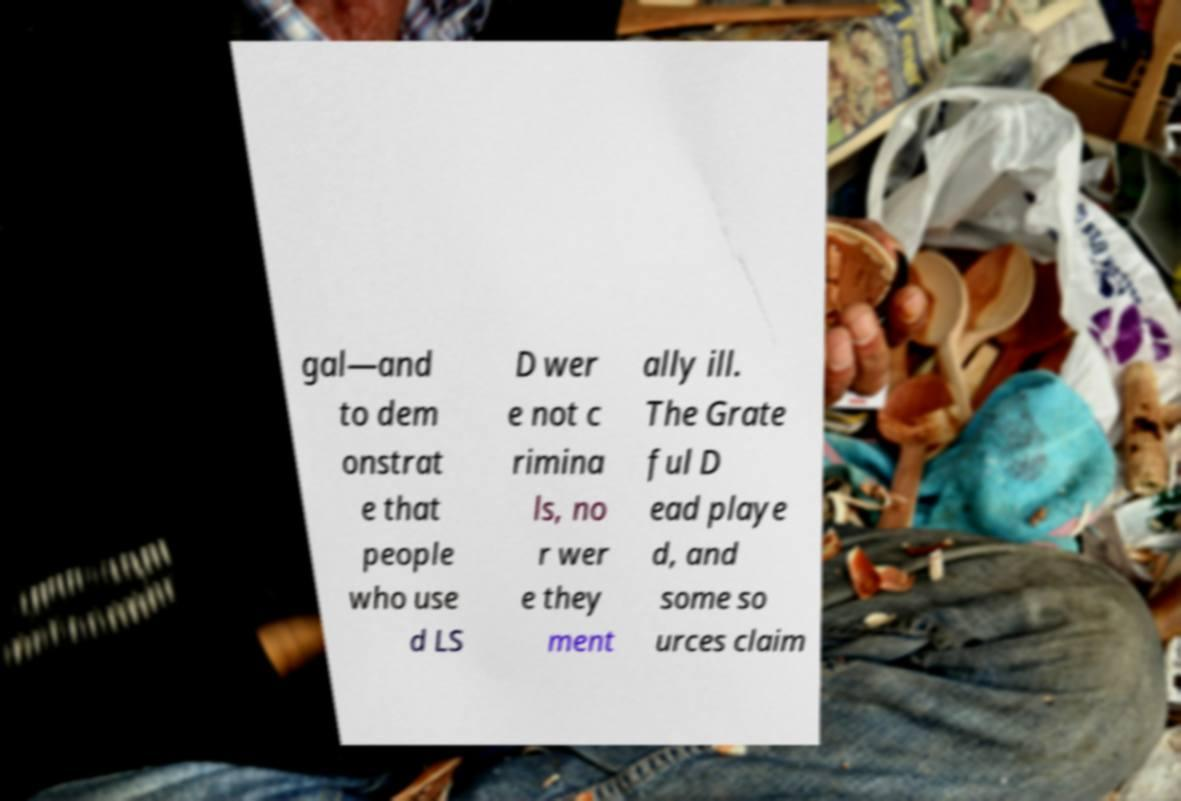Can you read and provide the text displayed in the image?This photo seems to have some interesting text. Can you extract and type it out for me? gal—and to dem onstrat e that people who use d LS D wer e not c rimina ls, no r wer e they ment ally ill. The Grate ful D ead playe d, and some so urces claim 